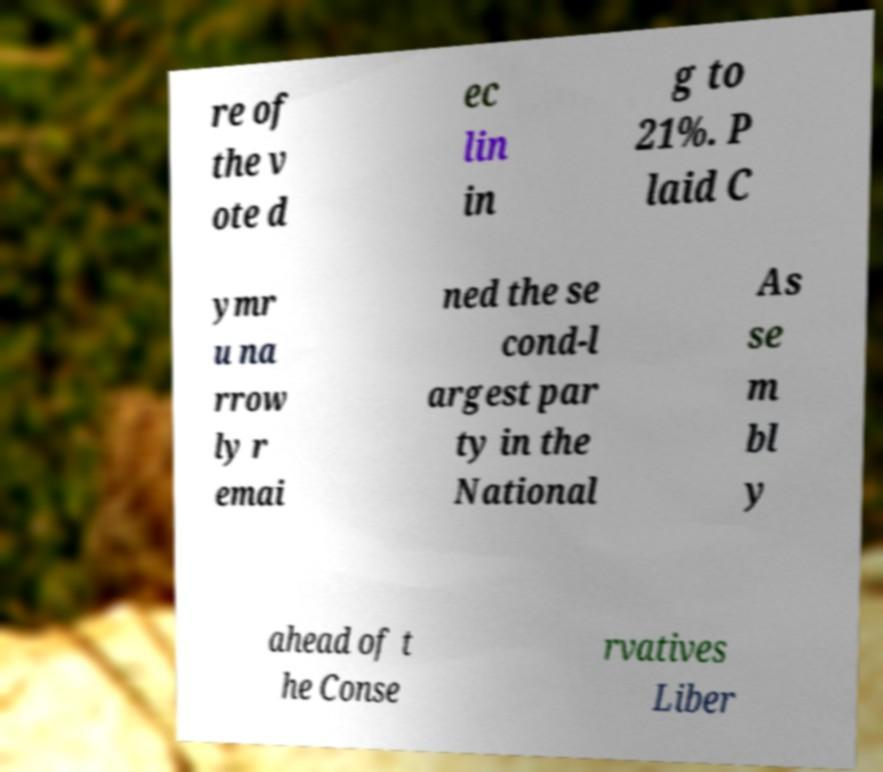Can you accurately transcribe the text from the provided image for me? re of the v ote d ec lin in g to 21%. P laid C ymr u na rrow ly r emai ned the se cond-l argest par ty in the National As se m bl y ahead of t he Conse rvatives Liber 